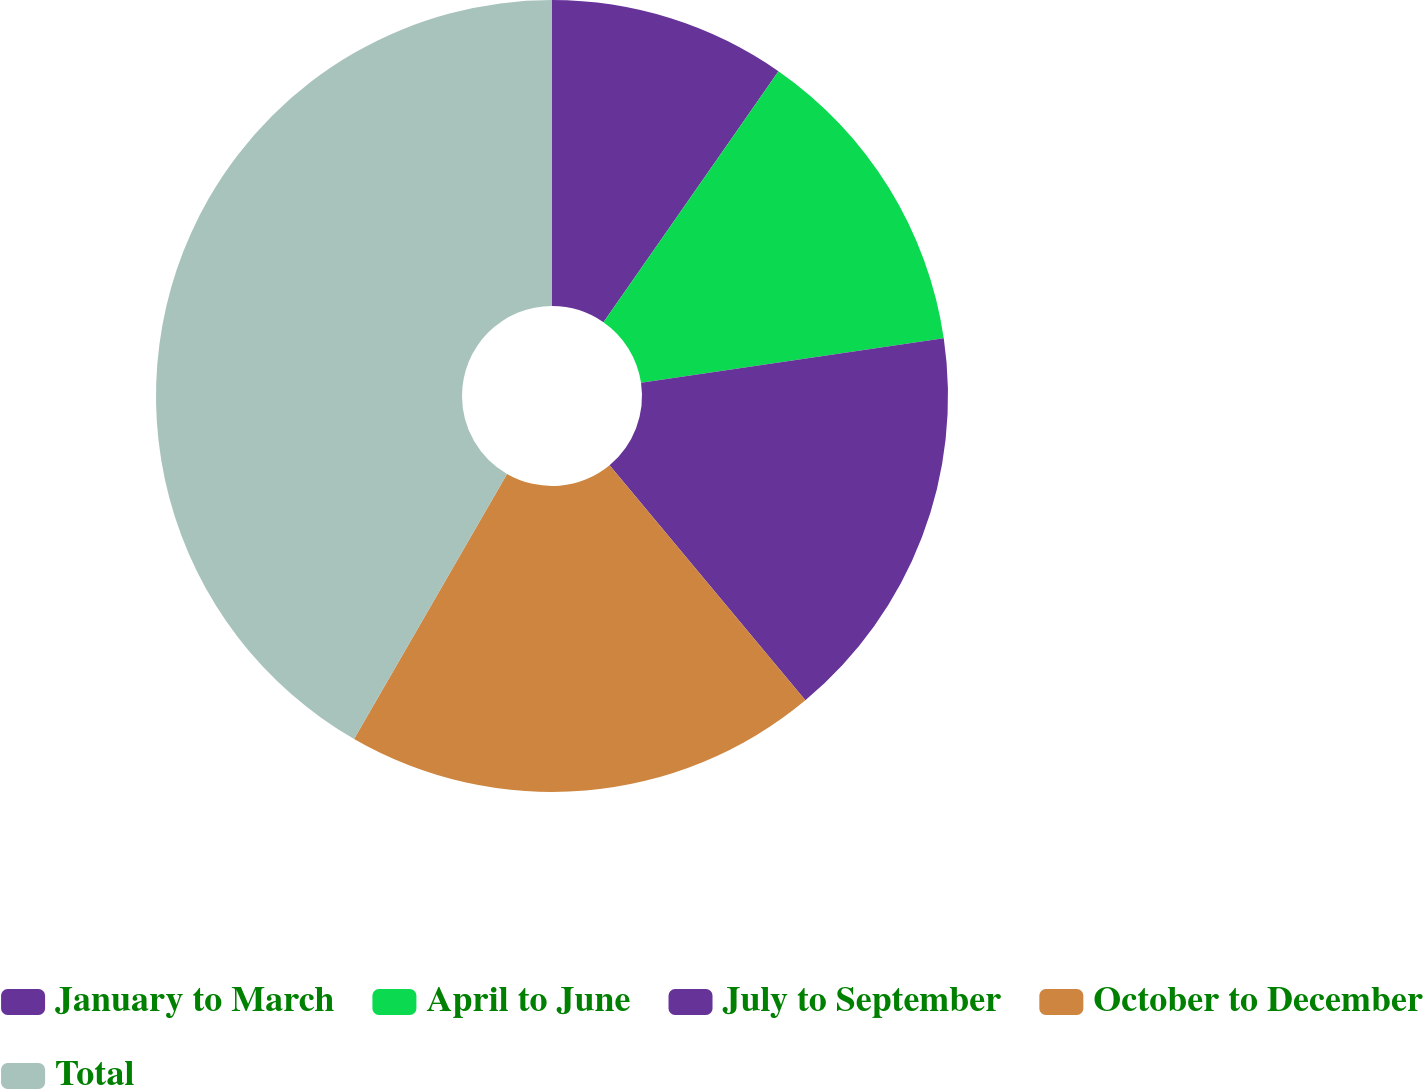Convert chart to OTSL. <chart><loc_0><loc_0><loc_500><loc_500><pie_chart><fcel>January to March<fcel>April to June<fcel>July to September<fcel>October to December<fcel>Total<nl><fcel>9.69%<fcel>12.98%<fcel>16.28%<fcel>19.38%<fcel>41.67%<nl></chart> 